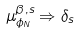Convert formula to latex. <formula><loc_0><loc_0><loc_500><loc_500>\mu _ { \phi _ { N } } ^ { \beta , s } \Rightarrow \delta _ { s } \,</formula> 